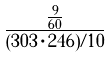Convert formula to latex. <formula><loc_0><loc_0><loc_500><loc_500>\frac { \frac { 9 } { 6 0 } } { ( 3 0 3 \cdot 2 4 6 ) / 1 0 }</formula> 